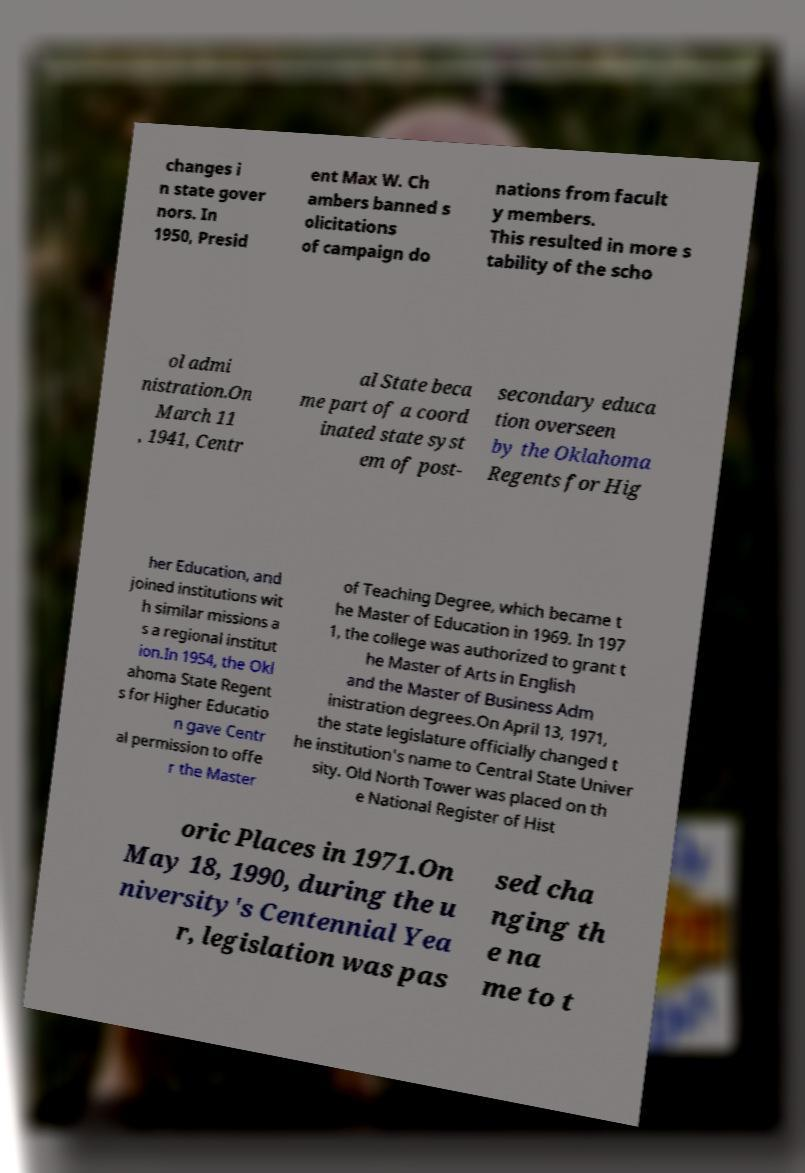Can you read and provide the text displayed in the image?This photo seems to have some interesting text. Can you extract and type it out for me? changes i n state gover nors. In 1950, Presid ent Max W. Ch ambers banned s olicitations of campaign do nations from facult y members. This resulted in more s tability of the scho ol admi nistration.On March 11 , 1941, Centr al State beca me part of a coord inated state syst em of post- secondary educa tion overseen by the Oklahoma Regents for Hig her Education, and joined institutions wit h similar missions a s a regional institut ion.In 1954, the Okl ahoma State Regent s for Higher Educatio n gave Centr al permission to offe r the Master of Teaching Degree, which became t he Master of Education in 1969. In 197 1, the college was authorized to grant t he Master of Arts in English and the Master of Business Adm inistration degrees.On April 13, 1971, the state legislature officially changed t he institution's name to Central State Univer sity. Old North Tower was placed on th e National Register of Hist oric Places in 1971.On May 18, 1990, during the u niversity's Centennial Yea r, legislation was pas sed cha nging th e na me to t 